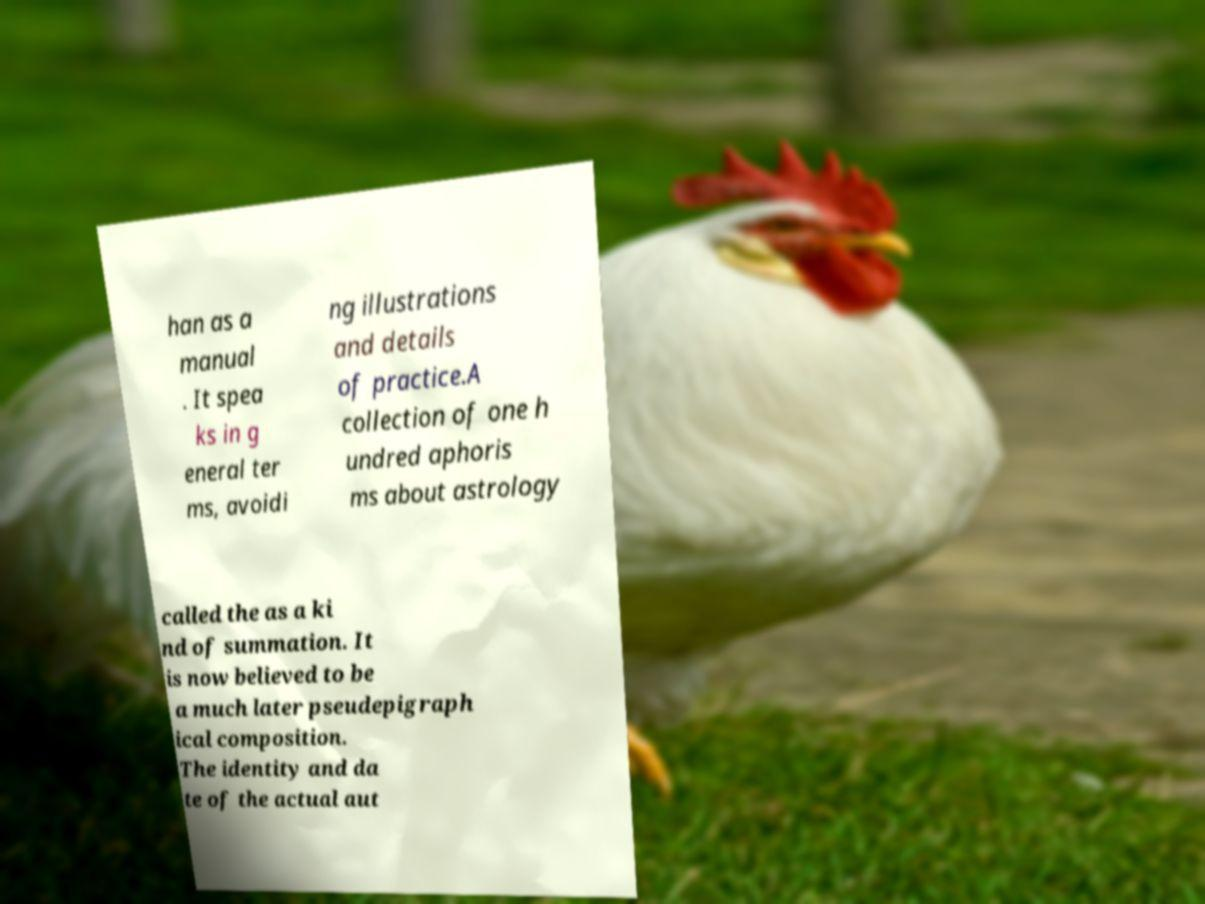I need the written content from this picture converted into text. Can you do that? han as a manual . It spea ks in g eneral ter ms, avoidi ng illustrations and details of practice.A collection of one h undred aphoris ms about astrology called the as a ki nd of summation. It is now believed to be a much later pseudepigraph ical composition. The identity and da te of the actual aut 